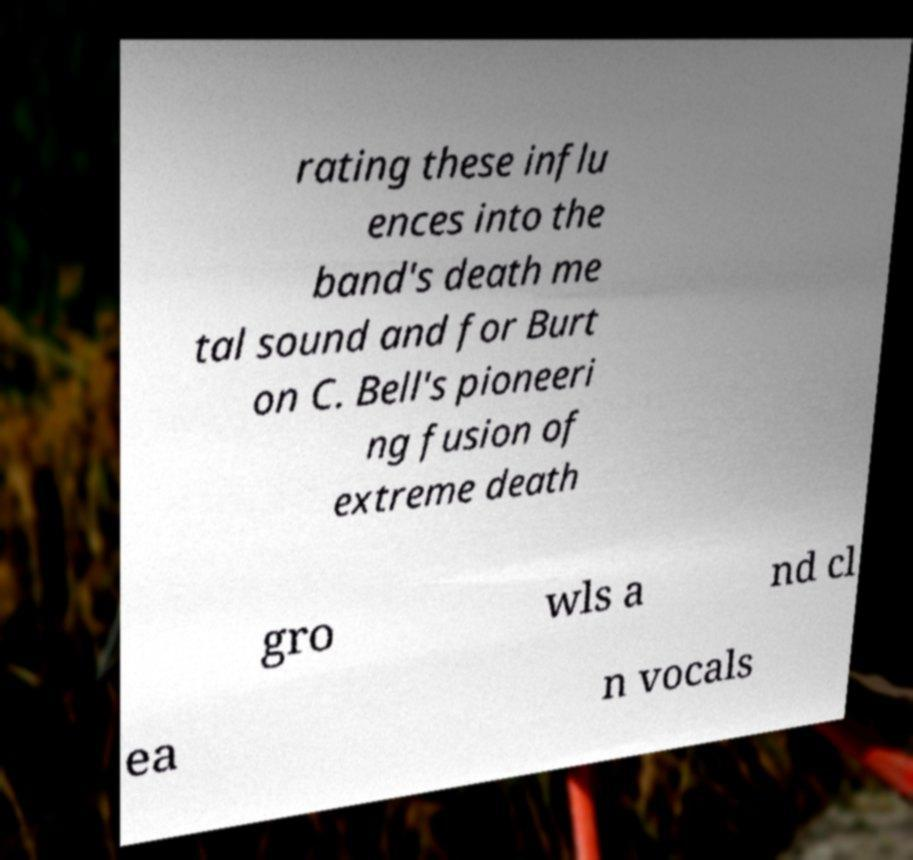Can you accurately transcribe the text from the provided image for me? rating these influ ences into the band's death me tal sound and for Burt on C. Bell's pioneeri ng fusion of extreme death gro wls a nd cl ea n vocals 